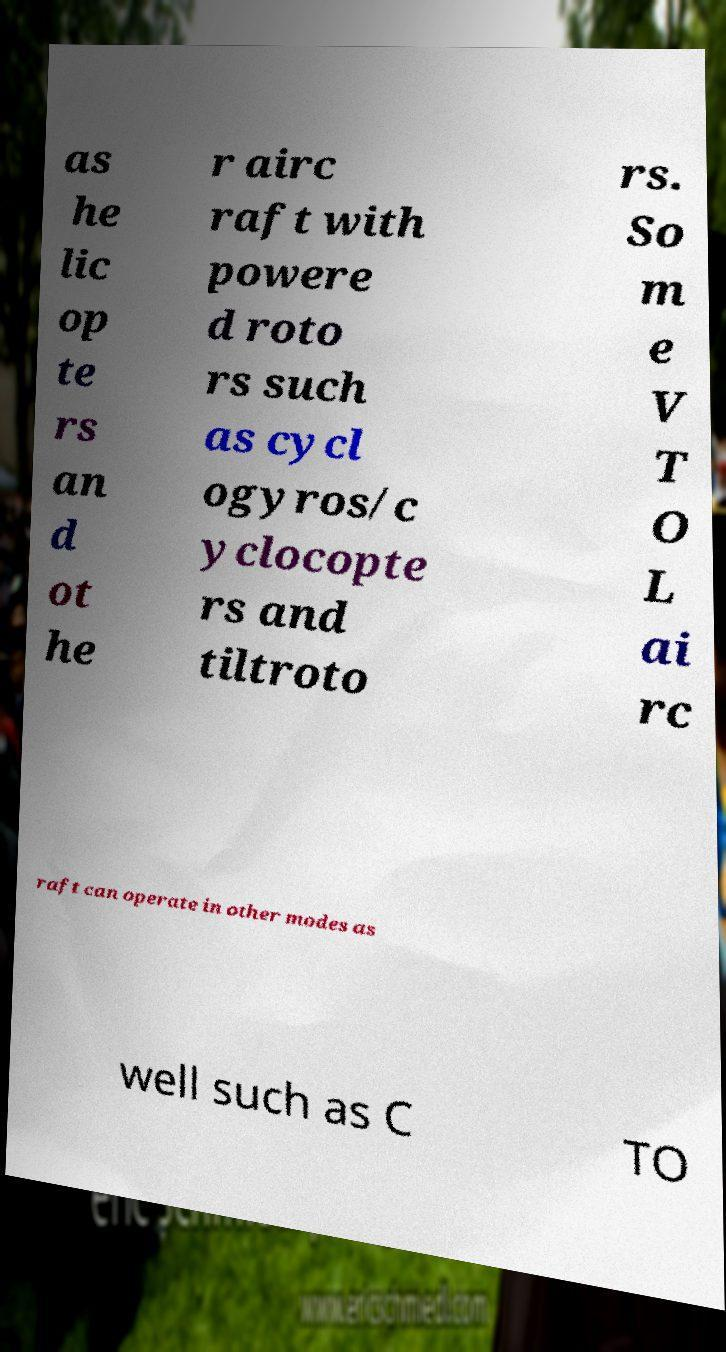Can you accurately transcribe the text from the provided image for me? as he lic op te rs an d ot he r airc raft with powere d roto rs such as cycl ogyros/c yclocopte rs and tiltroto rs. So m e V T O L ai rc raft can operate in other modes as well such as C TO 